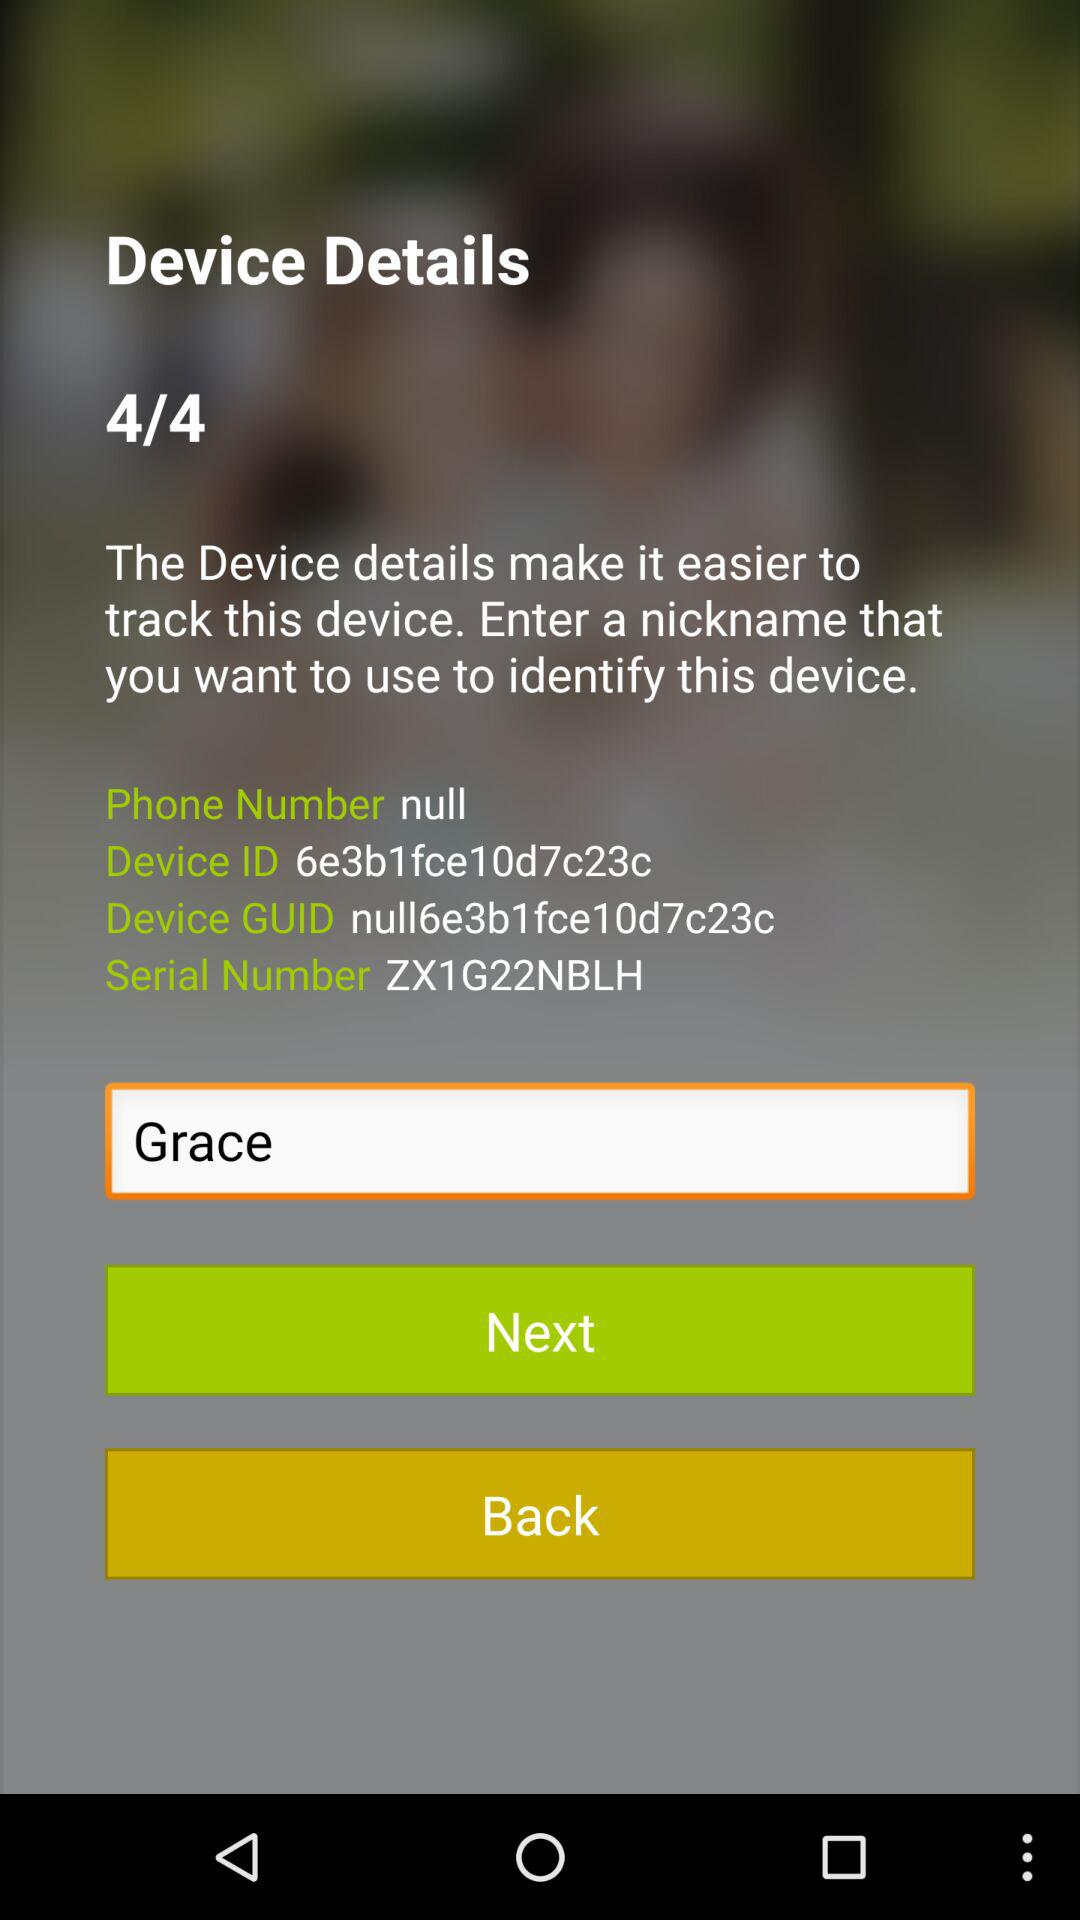What is the device GUID number? The device GUID number is null6e3b1fce10d7c23c. 